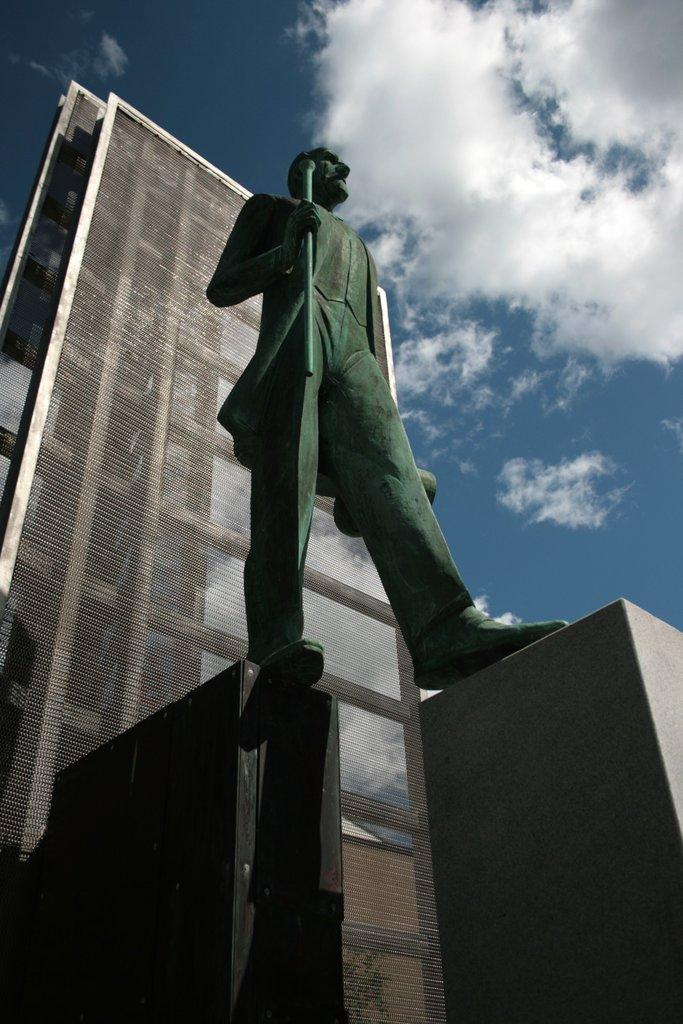What is the main subject of the image? There is a statue of a person in the image. What is the statue standing on? The statue is standing on a rock. What is the statue holding or associated with? There is a weapon associated with the statue. What can be seen in the background of the image? There is a wall in the background of the image. What is the condition of the sky in the image? The sky is clear in the image. Where are the toys placed in the image? There are no toys present in the image. What type of basin can be seen near the statue in the image? There is no basin present near the statue in the image. 